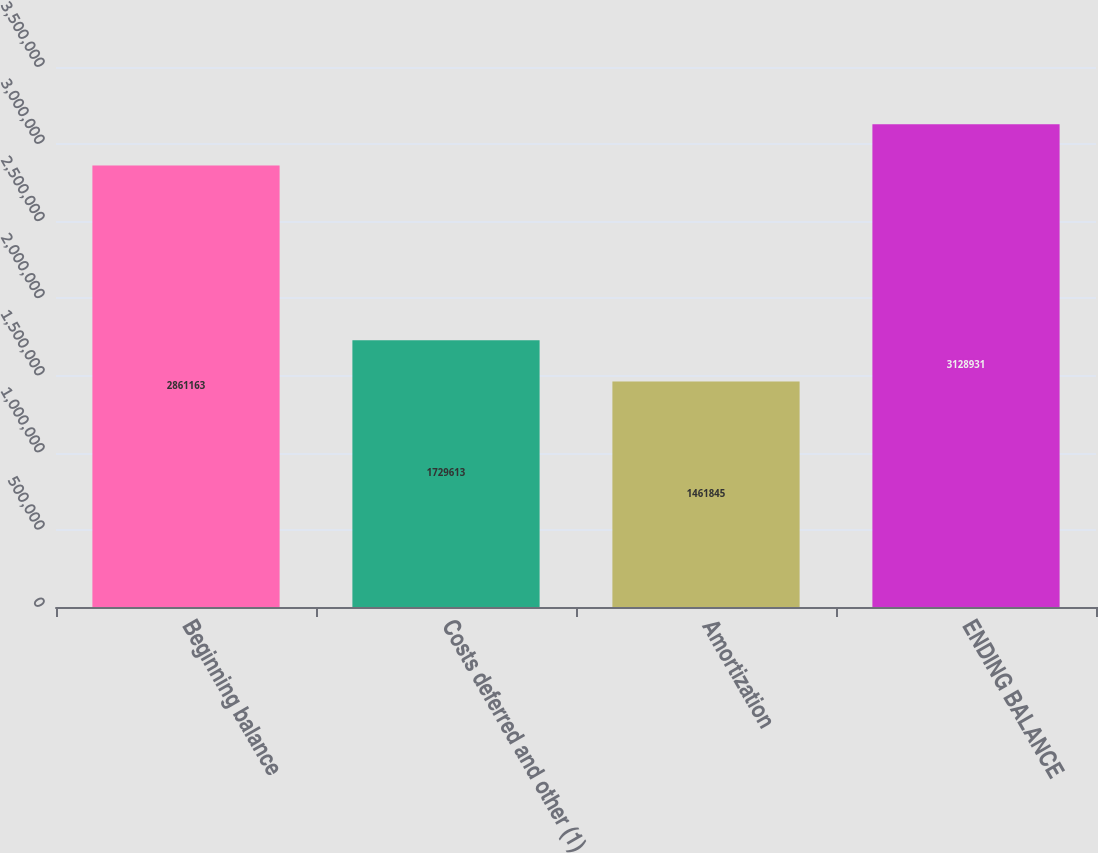<chart> <loc_0><loc_0><loc_500><loc_500><bar_chart><fcel>Beginning balance<fcel>Costs deferred and other (1)<fcel>Amortization<fcel>ENDING BALANCE<nl><fcel>2.86116e+06<fcel>1.72961e+06<fcel>1.46184e+06<fcel>3.12893e+06<nl></chart> 